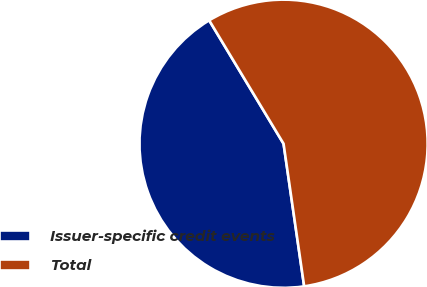<chart> <loc_0><loc_0><loc_500><loc_500><pie_chart><fcel>Issuer-specific credit events<fcel>Total<nl><fcel>43.65%<fcel>56.35%<nl></chart> 